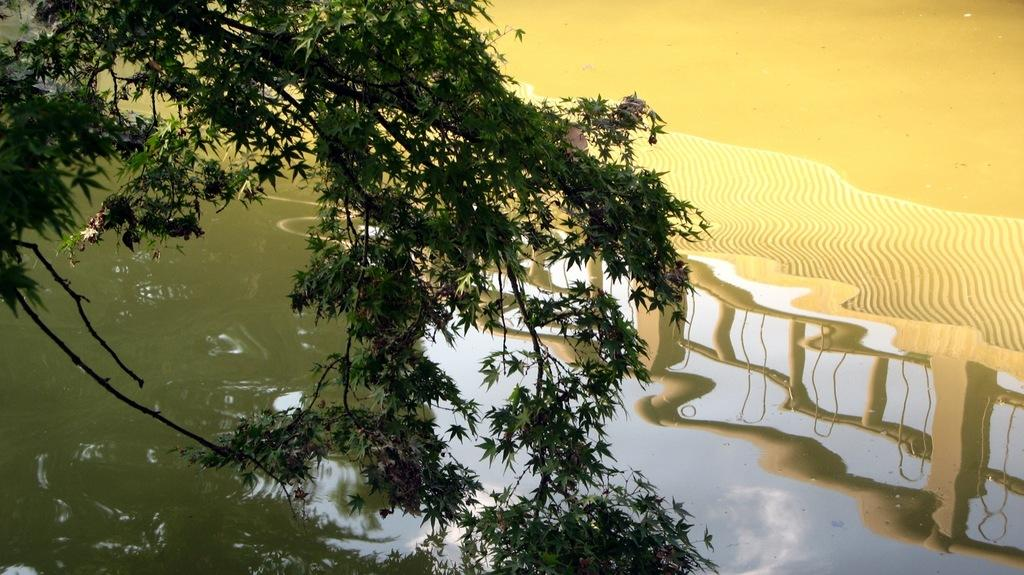What type of plant material is present in the image? There are leaves on stems in the image. What natural element is visible in the image? Water is visible in the image. What can be seen in the reflection of the water? The sky, trees, and the railing are visible in the reflection of the water. What type of belief system is being practiced by the carpenter in the image? There is no carpenter present in the image, and therefore no belief system can be observed. What type of vacation destination is depicted in the image? The image does not depict a vacation destination; it features leaves on stems, water, and reflections. 